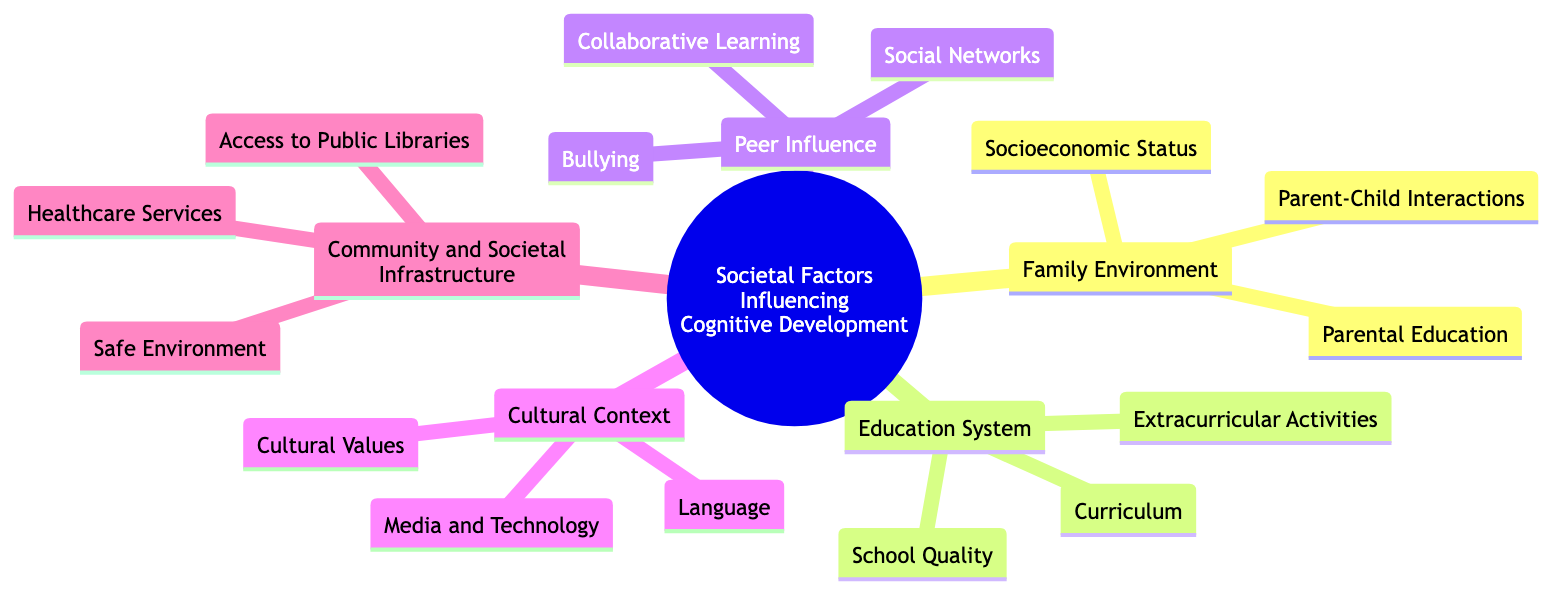What is the central topic of the mind map? The central topic is clearly labeled at the top of the diagram, which states "Societal Factors Influencing Cognitive Development."
Answer: Societal Factors Influencing Cognitive Development How many subtopics are present in the diagram? By counting the identified subtopics that branch off the central topic, we see there are five subtopics: Family Environment, Education System, Peer Influence, Cultural Context, and Community and Societal Infrastructure.
Answer: 5 What does "Parental Education" affect in children's development? In the diagram, the details for "Parental Education" explain that it impacts cognitive stimulation at home, which is essential for children's development.
Answer: Cognitive stimulation Which subtopic includes "School Quality"? Tracing the connections in the diagram, "School Quality" is found under the "Education System" subtopic, indicating that it relates directly to the quality of educational institutions.
Answer: Education System What are two elements that influence “Peer Influence”? Looking at the "Peer Influence" subtopic, the elements provided include "Social Networks" and "Bullying," which are key factors under this category.
Answer: Social Networks and Bullying How does “Healthcare Services” affect cognitive development? The element "Healthcare Services" under "Community and Societal Infrastructure" provides insight that it impacts cognitive development by affecting mental and physical health, which are crucial for overall cognitive functioning.
Answer: Mental and physical health What is the relationship between “Cultural Values” and cognitive development? The mind map outlines beneath "Cultural Context" that "Cultural Values" describes societal attitudes towards education and achievement, implying a direct influence on how cognitive development is perceived and nurtured within society.
Answer: Societal attitudes towards education Which two subtopics focus on out-of-home influences? The "Education System" and "Community and Societal Infrastructure" subtopics relate to factors that influence cognitive development outside of the family environment, such as schooling and community resources.
Answer: Education System and Community and Societal Infrastructure Name an element under “Cultural Context” that relates to language. The element "Language," described in the "Cultural Context" subtopic, is noted for its role in cognitive flexibility and bilingualism, underlining its importance in cognitive development.
Answer: Language 